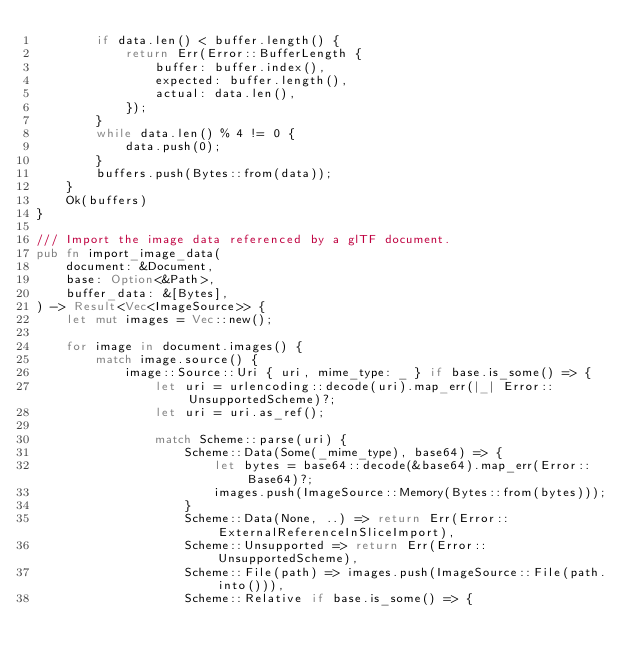<code> <loc_0><loc_0><loc_500><loc_500><_Rust_>        if data.len() < buffer.length() {
            return Err(Error::BufferLength {
                buffer: buffer.index(),
                expected: buffer.length(),
                actual: data.len(),
            });
        }
        while data.len() % 4 != 0 {
            data.push(0);
        }
        buffers.push(Bytes::from(data));
    }
    Ok(buffers)
}

/// Import the image data referenced by a glTF document.
pub fn import_image_data(
    document: &Document,
    base: Option<&Path>,
    buffer_data: &[Bytes],
) -> Result<Vec<ImageSource>> {
    let mut images = Vec::new();

    for image in document.images() {
        match image.source() {
            image::Source::Uri { uri, mime_type: _ } if base.is_some() => {
                let uri = urlencoding::decode(uri).map_err(|_| Error::UnsupportedScheme)?;
                let uri = uri.as_ref();

                match Scheme::parse(uri) {
                    Scheme::Data(Some(_mime_type), base64) => {
                        let bytes = base64::decode(&base64).map_err(Error::Base64)?;
                        images.push(ImageSource::Memory(Bytes::from(bytes)));
                    }
                    Scheme::Data(None, ..) => return Err(Error::ExternalReferenceInSliceImport),
                    Scheme::Unsupported => return Err(Error::UnsupportedScheme),
                    Scheme::File(path) => images.push(ImageSource::File(path.into())),
                    Scheme::Relative if base.is_some() => {</code> 